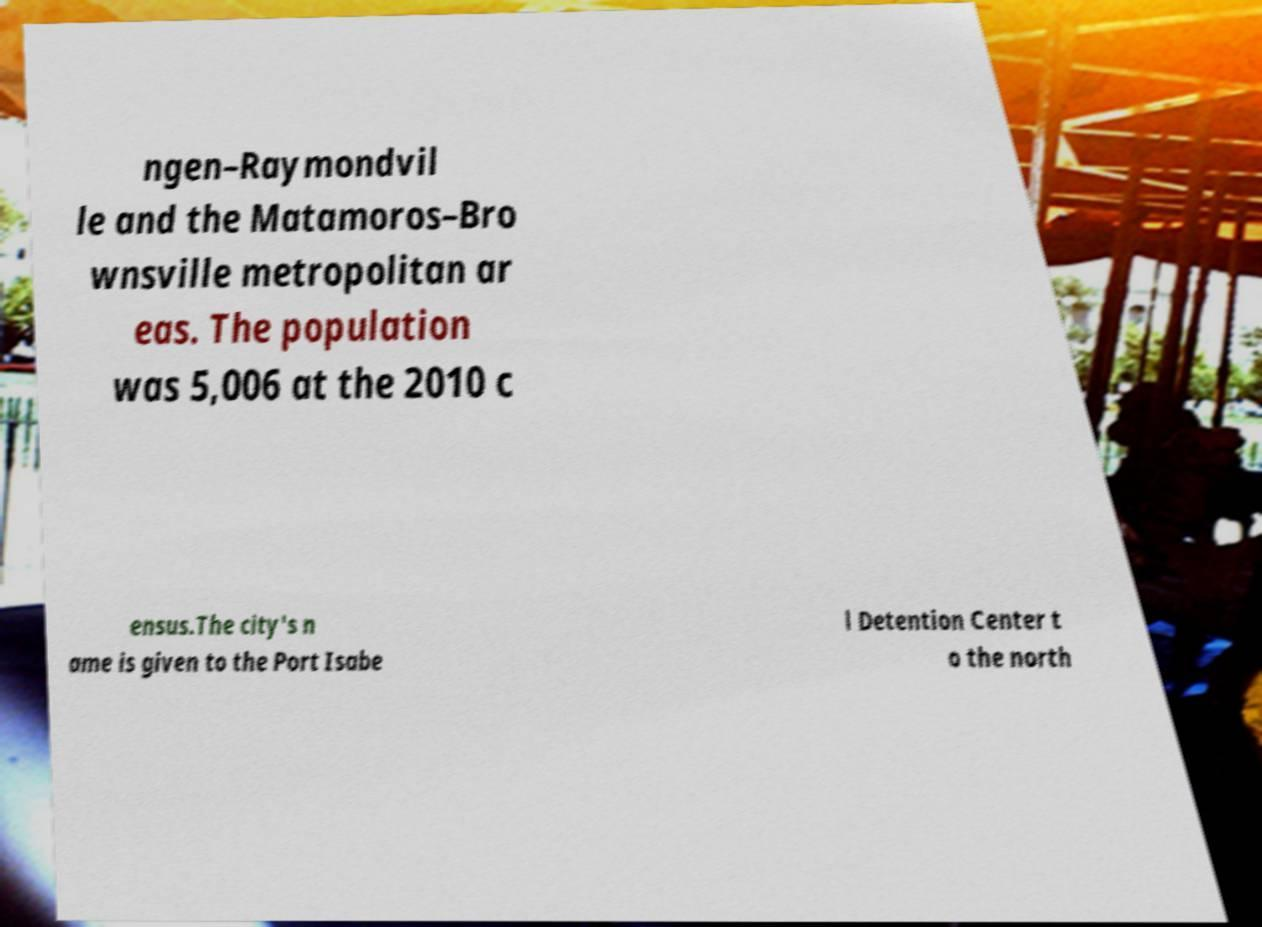Please read and relay the text visible in this image. What does it say? ngen–Raymondvil le and the Matamoros–Bro wnsville metropolitan ar eas. The population was 5,006 at the 2010 c ensus.The city's n ame is given to the Port Isabe l Detention Center t o the north 